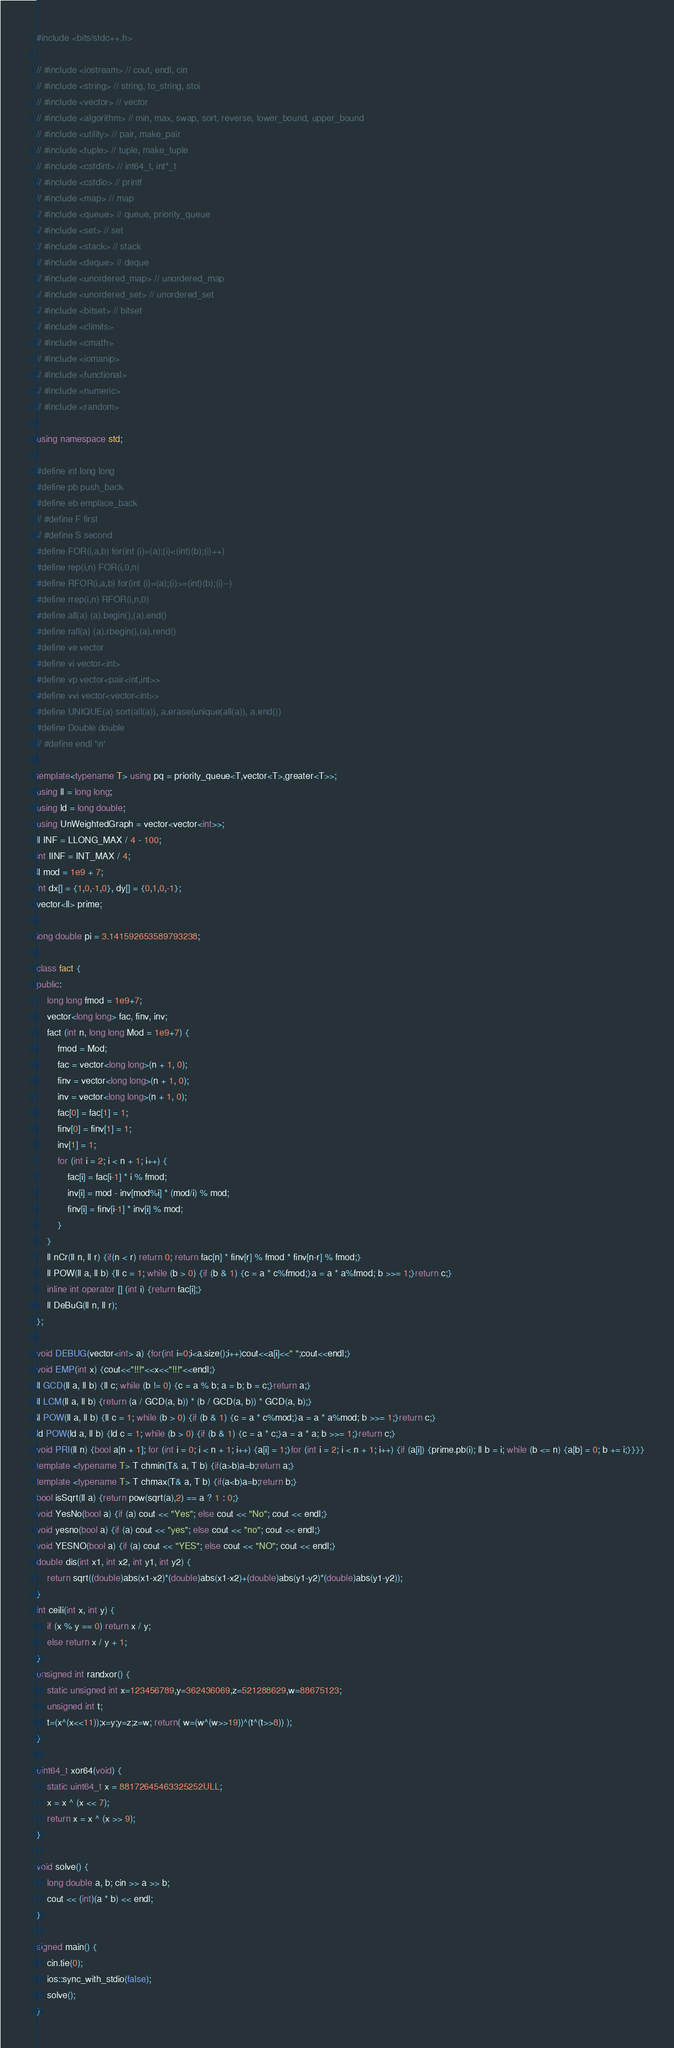Convert code to text. <code><loc_0><loc_0><loc_500><loc_500><_C++_>#include <bits/stdc++.h>

// #include <iostream> // cout, endl, cin
// #include <string> // string, to_string, stoi
// #include <vector> // vector
// #include <algorithm> // min, max, swap, sort, reverse, lower_bound, upper_bound
// #include <utility> // pair, make_pair
// #include <tuple> // tuple, make_tuple
// #include <cstdint> // int64_t, int*_t
// #include <cstdio> // printf
// #include <map> // map
// #include <queue> // queue, priority_queue
// #include <set> // set
// #include <stack> // stack
// #include <deque> // deque
// #include <unordered_map> // unordered_map
// #include <unordered_set> // unordered_set
// #include <bitset> // bitset
// #include <climits>
// #include <cmath>
// #include <iomanip>
// #include <functional>
// #include <numeric>
// #include <random>
 
using namespace std;

#define int long long
#define pb push_back
#define eb emplace_back
// #define F first
// #define S second
#define FOR(i,a,b) for(int (i)=(a);(i)<(int)(b);(i)++)
#define rep(i,n) FOR(i,0,n)
#define RFOR(i,a,b) for(int (i)=(a);(i)>=(int)(b);(i)--)
#define rrep(i,n) RFOR(i,n,0)
#define all(a) (a).begin(),(a).end()
#define rall(a) (a).rbegin(),(a).rend()
#define ve vector
#define vi vector<int>
#define vp vector<pair<int,int>>
#define vvi vector<vector<int>>
#define UNIQUE(a) sort(all(a)), a.erase(unique(all(a)), a.end())
#define Double double
// #define endl '\n'
 
template<typename T> using pq = priority_queue<T,vector<T>,greater<T>>; 
using ll = long long;
using ld = long double;
using UnWeightedGraph = vector<vector<int>>;
ll INF = LLONG_MAX / 4 - 100;
int IINF = INT_MAX / 4;
ll mod = 1e9 + 7;
int dx[] = {1,0,-1,0}, dy[] = {0,1,0,-1};
vector<ll> prime;
 
long double pi = 3.141592653589793238;
    
class fact {
public:
    long long fmod = 1e9+7;
    vector<long long> fac, finv, inv;
    fact (int n, long long Mod = 1e9+7) {
        fmod = Mod;
        fac = vector<long long>(n + 1, 0);
        finv = vector<long long>(n + 1, 0);
        inv = vector<long long>(n + 1, 0);
        fac[0] = fac[1] = 1;
        finv[0] = finv[1] = 1;
        inv[1] = 1; 
        for (int i = 2; i < n + 1; i++) {
            fac[i] = fac[i-1] * i % fmod;
            inv[i] = mod - inv[mod%i] * (mod/i) % mod;
            finv[i] = finv[i-1] * inv[i] % mod;
        }
    }
    ll nCr(ll n, ll r) {if(n < r) return 0; return fac[n] * finv[r] % fmod * finv[n-r] % fmod;}
    ll POW(ll a, ll b) {ll c = 1; while (b > 0) {if (b & 1) {c = a * c%fmod;}a = a * a%fmod; b >>= 1;}return c;}
    inline int operator [] (int i) {return fac[i];}
    ll DeBuG(ll n, ll r);
};
    
void DEBUG(vector<int> a) {for(int i=0;i<a.size();i++)cout<<a[i]<<" ";cout<<endl;}
void EMP(int x) {cout<<"!!!"<<x<<"!!!"<<endl;}
ll GCD(ll a, ll b) {ll c; while (b != 0) {c = a % b; a = b; b = c;}return a;}
ll LCM(ll a, ll b) {return (a / GCD(a, b)) * (b / GCD(a, b)) * GCD(a, b);}
ll POW(ll a, ll b) {ll c = 1; while (b > 0) {if (b & 1) {c = a * c%mod;}a = a * a%mod; b >>= 1;}return c;}
ld POW(ld a, ll b) {ld c = 1; while (b > 0) {if (b & 1) {c = a * c;}a = a * a; b >>= 1;}return c;}
void PRI(ll n) {bool a[n + 1]; for (int i = 0; i < n + 1; i++) {a[i] = 1;}for (int i = 2; i < n + 1; i++) {if (a[i]) {prime.pb(i); ll b = i; while (b <= n) {a[b] = 0; b += i;}}}}
template <typename T> T chmin(T& a, T b) {if(a>b)a=b;return a;}
template <typename T> T chmax(T& a, T b) {if(a<b)a=b;return b;}
bool isSqrt(ll a) {return pow(sqrt(a),2) == a ? 1 : 0;}
void YesNo(bool a) {if (a) cout << "Yes"; else cout << "No"; cout << endl;}
void yesno(bool a) {if (a) cout << "yes"; else cout << "no"; cout << endl;}
void YESNO(bool a) {if (a) cout << "YES"; else cout << "NO"; cout << endl;}
double dis(int x1, int x2, int y1, int y2) {
    return sqrt((double)abs(x1-x2)*(double)abs(x1-x2)+(double)abs(y1-y2)*(double)abs(y1-y2));
}
int ceili(int x, int y) {
    if (x % y == 0) return x / y;
    else return x / y + 1;
}
unsigned int randxor() {
    static unsigned int x=123456789,y=362436069,z=521288629,w=88675123;
    unsigned int t;
    t=(x^(x<<11));x=y;y=z;z=w; return( w=(w^(w>>19))^(t^(t>>8)) );
}
 
uint64_t xor64(void) {
    static uint64_t x = 88172645463325252ULL;
    x = x ^ (x << 7);
    return x = x ^ (x >> 9);
}

void solve() {
    long double a, b; cin >> a >> b;
    cout << (int)(a * b) << endl;
}

signed main() {
    cin.tie(0);
    ios::sync_with_stdio(false);
    solve();
}
</code> 